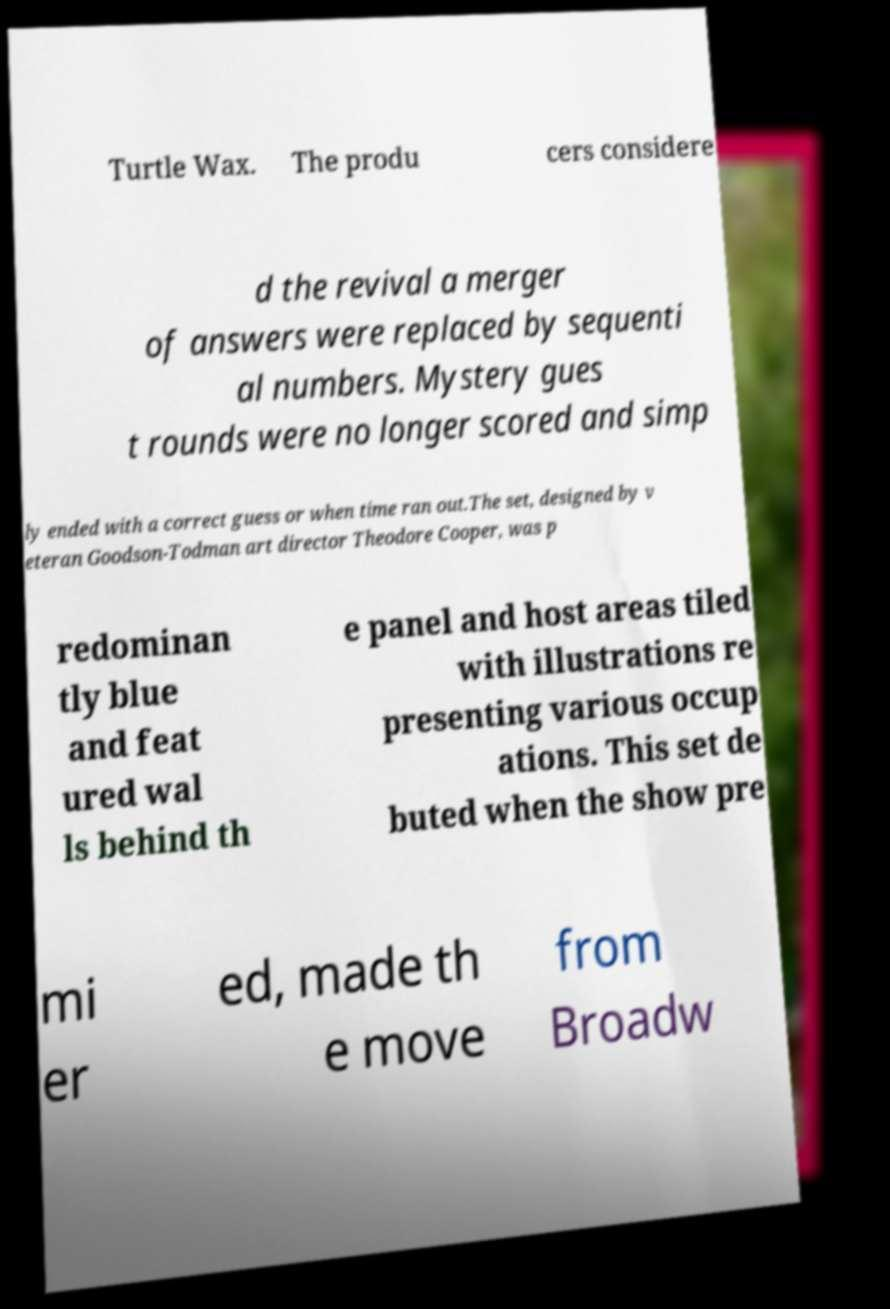Can you accurately transcribe the text from the provided image for me? Turtle Wax. The produ cers considere d the revival a merger of answers were replaced by sequenti al numbers. Mystery gues t rounds were no longer scored and simp ly ended with a correct guess or when time ran out.The set, designed by v eteran Goodson-Todman art director Theodore Cooper, was p redominan tly blue and feat ured wal ls behind th e panel and host areas tiled with illustrations re presenting various occup ations. This set de buted when the show pre mi er ed, made th e move from Broadw 